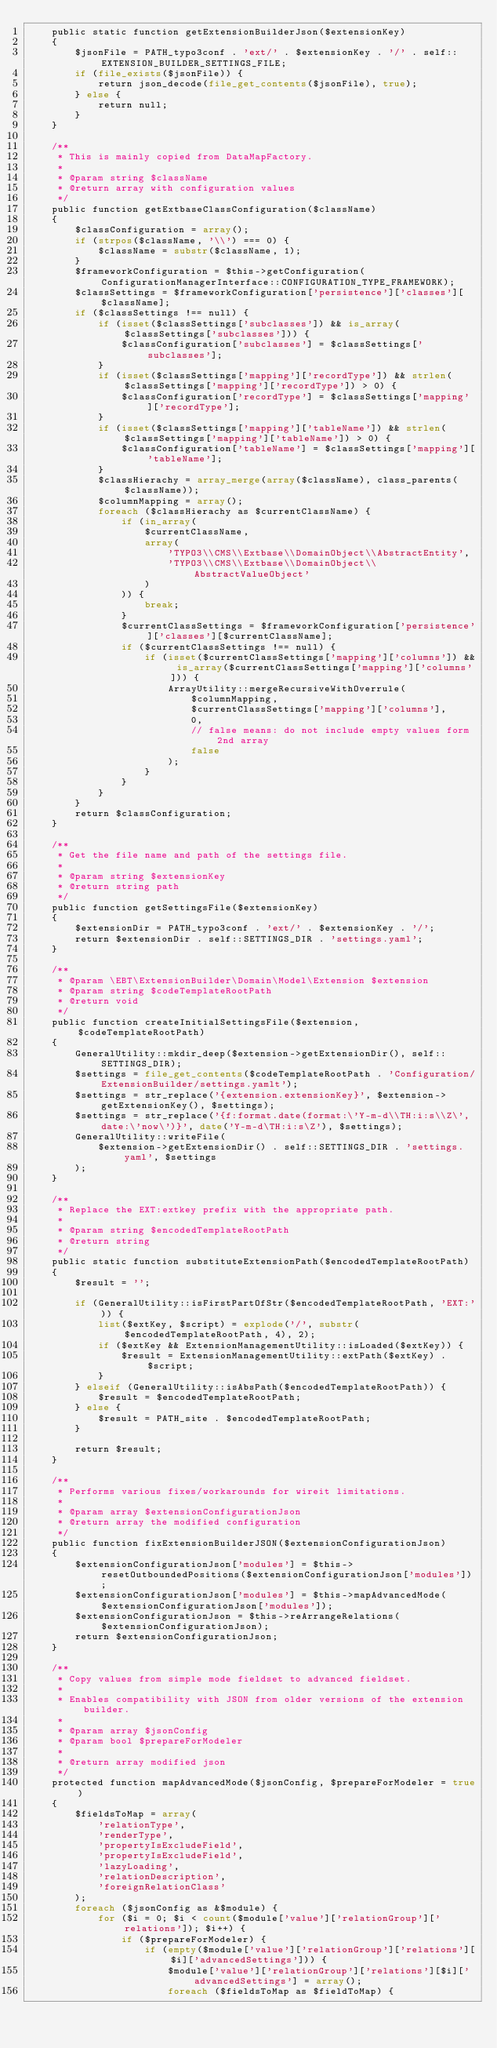Convert code to text. <code><loc_0><loc_0><loc_500><loc_500><_PHP_>    public static function getExtensionBuilderJson($extensionKey)
    {
        $jsonFile = PATH_typo3conf . 'ext/' . $extensionKey . '/' . self::EXTENSION_BUILDER_SETTINGS_FILE;
        if (file_exists($jsonFile)) {
            return json_decode(file_get_contents($jsonFile), true);
        } else {
            return null;
        }
    }

    /**
     * This is mainly copied from DataMapFactory.
     *
     * @param string $className
     * @return array with configuration values
     */
    public function getExtbaseClassConfiguration($className)
    {
        $classConfiguration = array();
        if (strpos($className, '\\') === 0) {
            $className = substr($className, 1);
        }
        $frameworkConfiguration = $this->getConfiguration(ConfigurationManagerInterface::CONFIGURATION_TYPE_FRAMEWORK);
        $classSettings = $frameworkConfiguration['persistence']['classes'][$className];
        if ($classSettings !== null) {
            if (isset($classSettings['subclasses']) && is_array($classSettings['subclasses'])) {
                $classConfiguration['subclasses'] = $classSettings['subclasses'];
            }
            if (isset($classSettings['mapping']['recordType']) && strlen($classSettings['mapping']['recordType']) > 0) {
                $classConfiguration['recordType'] = $classSettings['mapping']['recordType'];
            }
            if (isset($classSettings['mapping']['tableName']) && strlen($classSettings['mapping']['tableName']) > 0) {
                $classConfiguration['tableName'] = $classSettings['mapping']['tableName'];
            }
            $classHierachy = array_merge(array($className), class_parents($className));
            $columnMapping = array();
            foreach ($classHierachy as $currentClassName) {
                if (in_array(
                    $currentClassName,
                    array(
                        'TYPO3\\CMS\\Extbase\\DomainObject\\AbstractEntity',
                        'TYPO3\\CMS\\Extbase\\DomainObject\\AbstractValueObject'
                    )
                )) {
                    break;
                }
                $currentClassSettings = $frameworkConfiguration['persistence']['classes'][$currentClassName];
                if ($currentClassSettings !== null) {
                    if (isset($currentClassSettings['mapping']['columns']) && is_array($currentClassSettings['mapping']['columns'])) {
                        ArrayUtility::mergeRecursiveWithOverrule(
                            $columnMapping,
                            $currentClassSettings['mapping']['columns'],
                            0,
                            // false means: do not include empty values form 2nd array
                            false
                        );
                    }
                }
            }
        }
        return $classConfiguration;
    }

    /**
     * Get the file name and path of the settings file.
     *
     * @param string $extensionKey
     * @return string path
     */
    public function getSettingsFile($extensionKey)
    {
        $extensionDir = PATH_typo3conf . 'ext/' . $extensionKey . '/';
        return $extensionDir . self::SETTINGS_DIR . 'settings.yaml';
    }

    /**
     * @param \EBT\ExtensionBuilder\Domain\Model\Extension $extension
     * @param string $codeTemplateRootPath
     * @return void
     */
    public function createInitialSettingsFile($extension, $codeTemplateRootPath)
    {
        GeneralUtility::mkdir_deep($extension->getExtensionDir(), self::SETTINGS_DIR);
        $settings = file_get_contents($codeTemplateRootPath . 'Configuration/ExtensionBuilder/settings.yamlt');
        $settings = str_replace('{extension.extensionKey}', $extension->getExtensionKey(), $settings);
        $settings = str_replace('{f:format.date(format:\'Y-m-d\\TH:i:s\\Z\',date:\'now\')}', date('Y-m-d\TH:i:s\Z'), $settings);
        GeneralUtility::writeFile(
            $extension->getExtensionDir() . self::SETTINGS_DIR . 'settings.yaml', $settings
        );
    }

    /**
     * Replace the EXT:extkey prefix with the appropriate path.
     *
     * @param string $encodedTemplateRootPath
     * @return string
     */
    public static function substituteExtensionPath($encodedTemplateRootPath)
    {
        $result = '';

        if (GeneralUtility::isFirstPartOfStr($encodedTemplateRootPath, 'EXT:')) {
            list($extKey, $script) = explode('/', substr($encodedTemplateRootPath, 4), 2);
            if ($extKey && ExtensionManagementUtility::isLoaded($extKey)) {
                $result = ExtensionManagementUtility::extPath($extKey) . $script;
            }
        } elseif (GeneralUtility::isAbsPath($encodedTemplateRootPath)) {
            $result = $encodedTemplateRootPath;
        } else {
            $result = PATH_site . $encodedTemplateRootPath;
        }

        return $result;
    }

    /**
     * Performs various fixes/workarounds for wireit limitations.
     *
     * @param array $extensionConfigurationJson
     * @return array the modified configuration
     */
    public function fixExtensionBuilderJSON($extensionConfigurationJson)
    {
        $extensionConfigurationJson['modules'] = $this->resetOutboundedPositions($extensionConfigurationJson['modules']);
        $extensionConfigurationJson['modules'] = $this->mapAdvancedMode($extensionConfigurationJson['modules']);
        $extensionConfigurationJson = $this->reArrangeRelations($extensionConfigurationJson);
        return $extensionConfigurationJson;
    }

    /**
     * Copy values from simple mode fieldset to advanced fieldset.
     *
     * Enables compatibility with JSON from older versions of the extension builder.
     *
     * @param array $jsonConfig
     * @param bool $prepareForModeler
     *
     * @return array modified json
     */
    protected function mapAdvancedMode($jsonConfig, $prepareForModeler = true)
    {
        $fieldsToMap = array(
            'relationType',
            'renderType',
            'propertyIsExcludeField',
            'propertyIsExcludeField',
            'lazyLoading',
            'relationDescription',
            'foreignRelationClass'
        );
        foreach ($jsonConfig as &$module) {
            for ($i = 0; $i < count($module['value']['relationGroup']['relations']); $i++) {
                if ($prepareForModeler) {
                    if (empty($module['value']['relationGroup']['relations'][$i]['advancedSettings'])) {
                        $module['value']['relationGroup']['relations'][$i]['advancedSettings'] = array();
                        foreach ($fieldsToMap as $fieldToMap) {</code> 